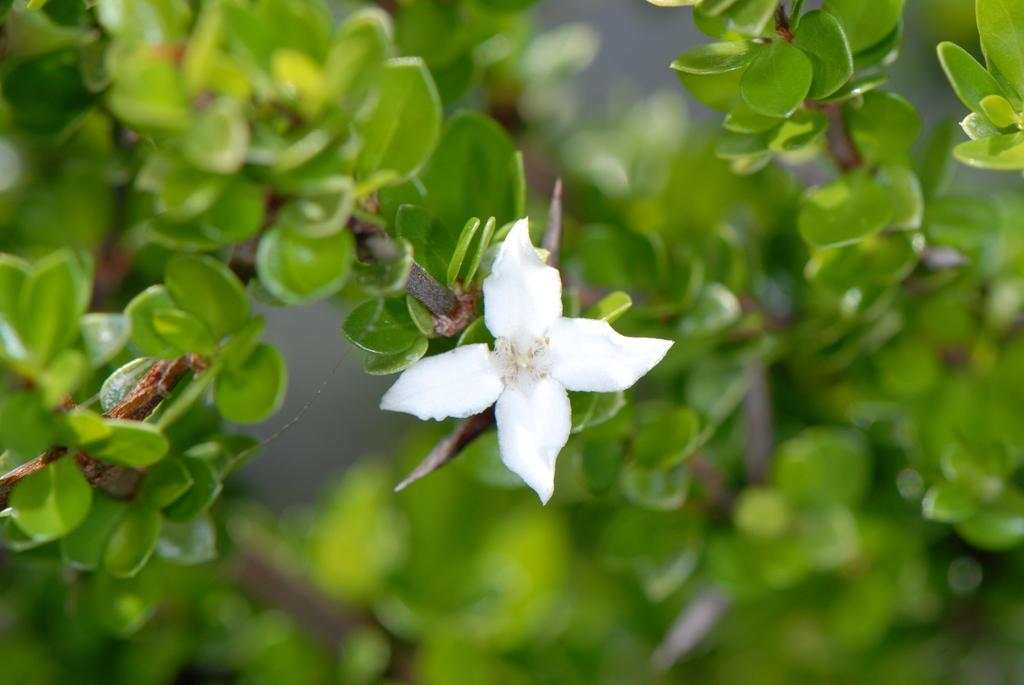What type of living organism is in the image? There is a plant in the image. What are the main features of the plant? The plant has leaves and a flower. What color is the flower on the plant? The flower is white in color. Can you describe the background of the image? The background of the image is blurred. Is there a jar covering the plant in the image? No, there is no jar present in the image. What type of event is taking place in the image? There is no event depicted in the image; it simply shows a plant with a white flower and blurred background. 